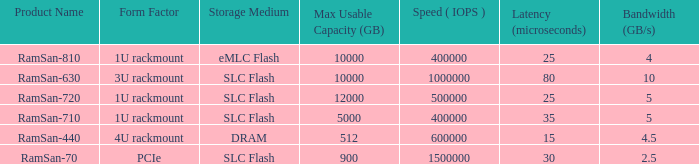What is the shape distortion for the range frequency of 10? 3U rackmount. 